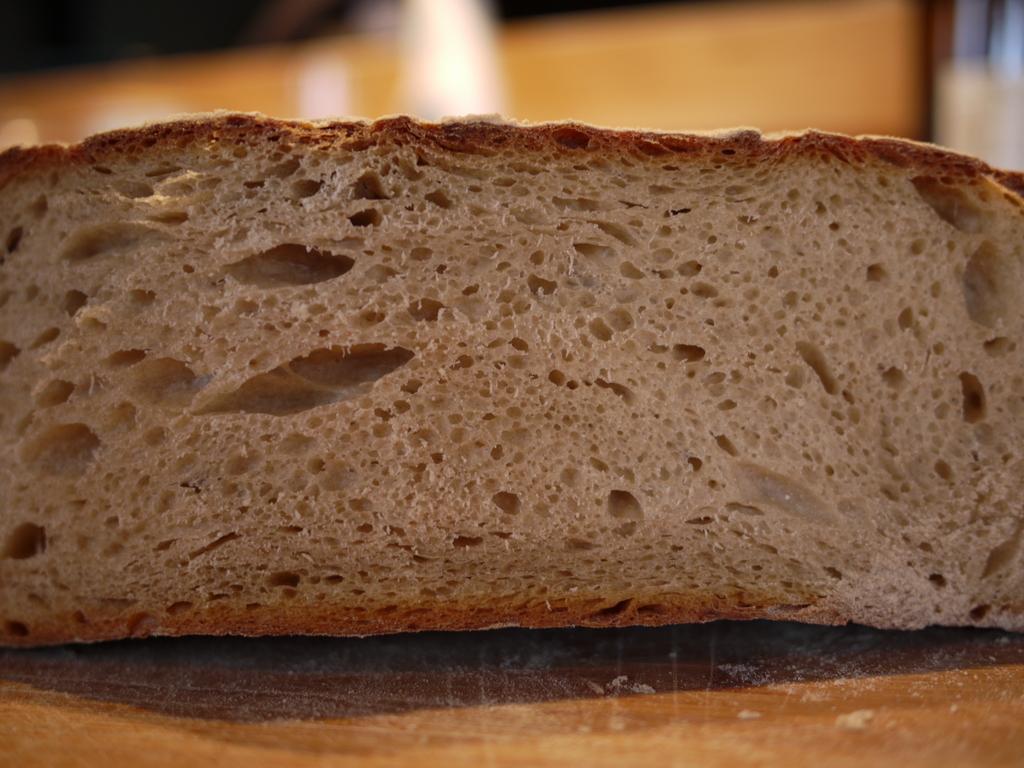How would you summarize this image in a sentence or two? In this image we can see a bread piece on a platform. In the background the image is blur but we can see objects. 